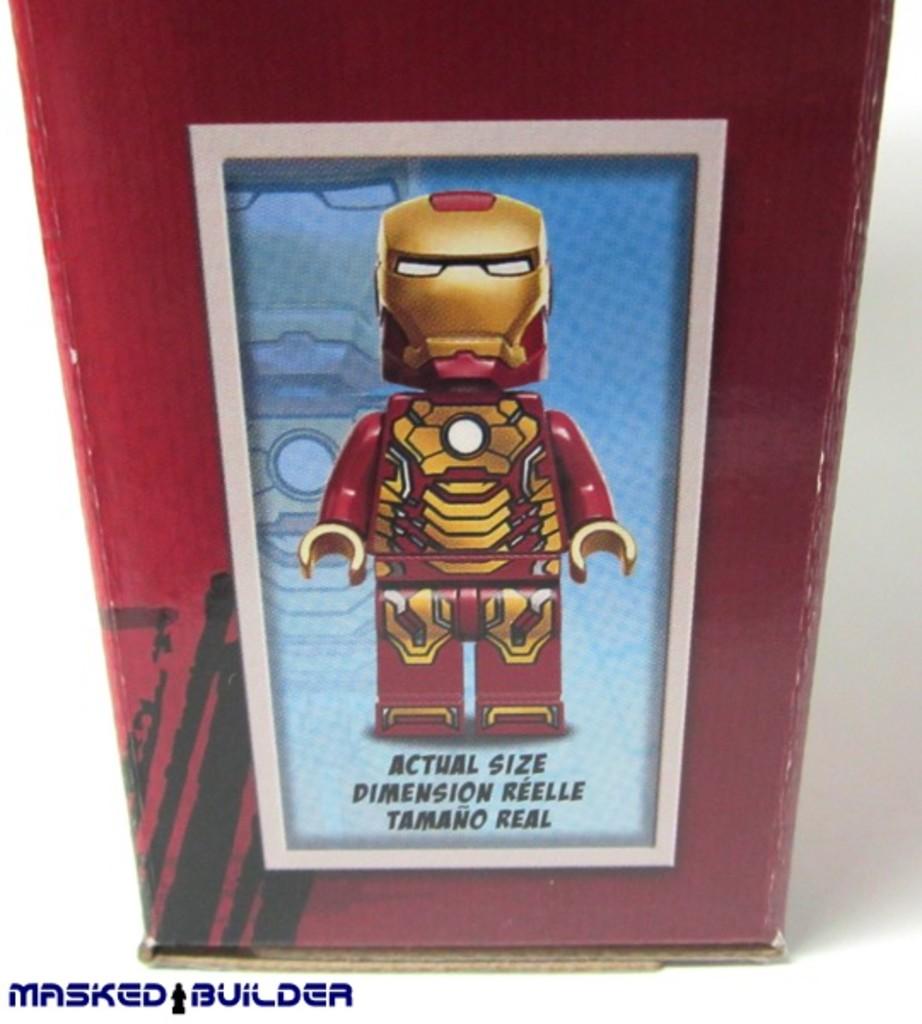Is the picture of the product what it really looks like?
Provide a short and direct response. Yes. There are delete botton?
Your answer should be compact. No. 